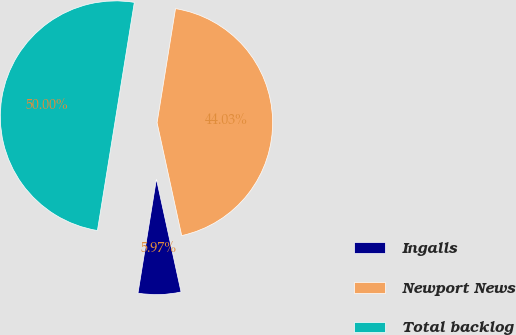Convert chart to OTSL. <chart><loc_0><loc_0><loc_500><loc_500><pie_chart><fcel>Ingalls<fcel>Newport News<fcel>Total backlog<nl><fcel>5.97%<fcel>44.03%<fcel>50.0%<nl></chart> 